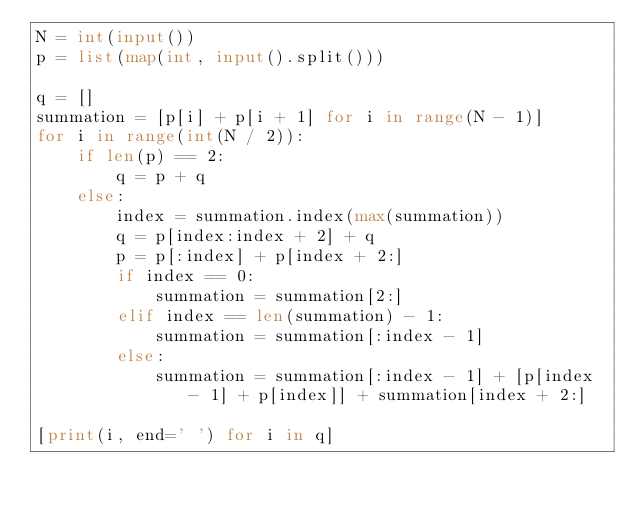<code> <loc_0><loc_0><loc_500><loc_500><_Python_>N = int(input())
p = list(map(int, input().split()))

q = []
summation = [p[i] + p[i + 1] for i in range(N - 1)]
for i in range(int(N / 2)):
    if len(p) == 2:
        q = p + q
    else:
        index = summation.index(max(summation))
        q = p[index:index + 2] + q
        p = p[:index] + p[index + 2:]
        if index == 0:
            summation = summation[2:]
        elif index == len(summation) - 1:
            summation = summation[:index - 1]
        else:
            summation = summation[:index - 1] + [p[index - 1] + p[index]] + summation[index + 2:]

[print(i, end=' ') for i in q]</code> 